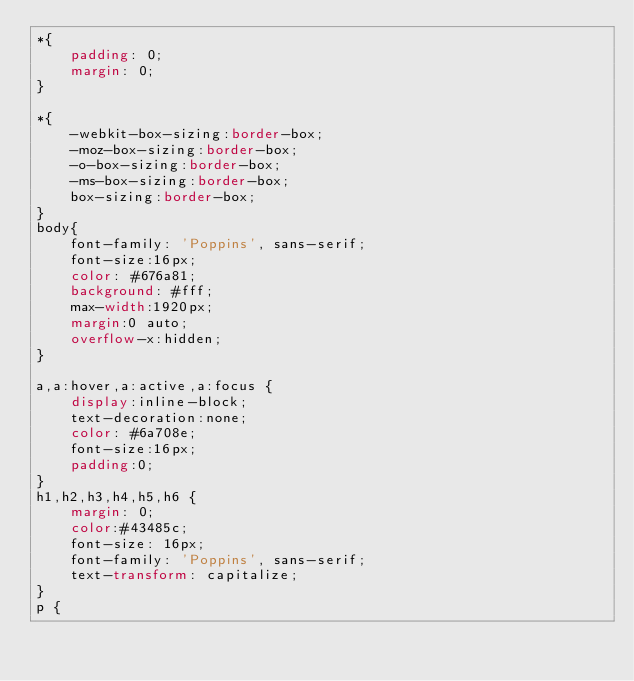<code> <loc_0><loc_0><loc_500><loc_500><_CSS_>*{
    padding: 0;
    margin: 0;
}

*{
    -webkit-box-sizing:border-box;
    -moz-box-sizing:border-box;
    -o-box-sizing:border-box;
    -ms-box-sizing:border-box;
    box-sizing:border-box;
}
body{
    font-family: 'Poppins', sans-serif;
    font-size:16px;
    color: #676a81;
    background: #fff;
    max-width:1920px;
    margin:0 auto;
    overflow-x:hidden;
}

a,a:hover,a:active,a:focus {
    display:inline-block;
    text-decoration:none;
    color: #6a708e;
    font-size:16px;
    padding:0;
}
h1,h2,h3,h4,h5,h6 { 
    margin: 0;
    color:#43485c;
    font-size: 16px;
    font-family: 'Poppins', sans-serif;
    text-transform: capitalize;
}
p {</code> 